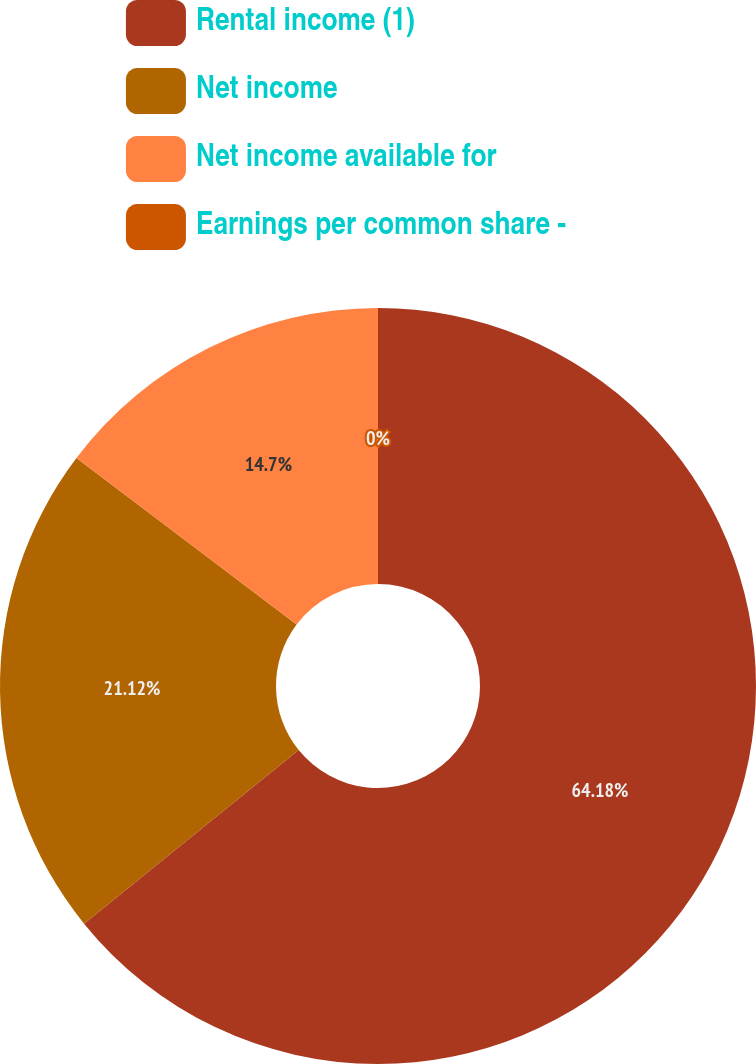Convert chart to OTSL. <chart><loc_0><loc_0><loc_500><loc_500><pie_chart><fcel>Rental income (1)<fcel>Net income<fcel>Net income available for<fcel>Earnings per common share -<nl><fcel>64.18%<fcel>21.12%<fcel>14.7%<fcel>0.0%<nl></chart> 